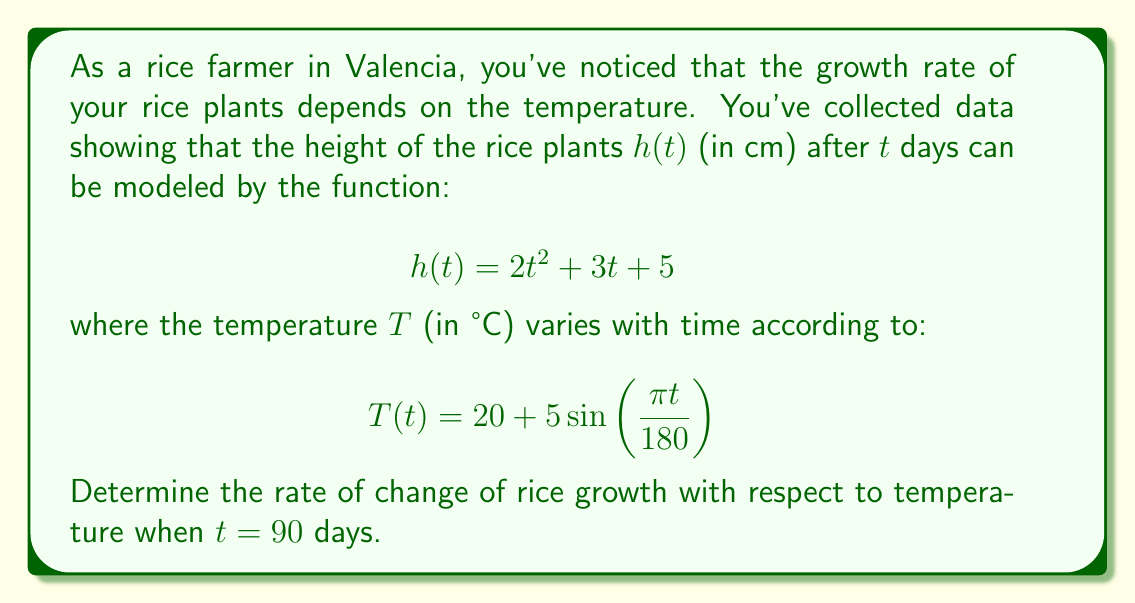Can you solve this math problem? To solve this problem, we need to use the chain rule from calculus. We want to find $\frac{dh}{dT}$ when $t = 90$.

Step 1: Find $\frac{dh}{dt}$
$$\frac{dh}{dt} = \frac{d}{dt}(2t^2 + 3t + 5) = 4t + 3$$

Step 2: Find $\frac{dT}{dt}$
$$\frac{dT}{dt} = \frac{d}{dt}(20 + 5\sin(\frac{\pi t}{180})) = 5 \cdot \frac{\pi}{180} \cos(\frac{\pi t}{180}) = \frac{\pi}{36} \cos(\frac{\pi t}{180})$$

Step 3: Use the chain rule
$$\frac{dh}{dT} = \frac{dh}{dt} \cdot \frac{dt}{dT} = \frac{dh}{dt} \cdot \frac{1}{\frac{dT}{dt}}$$

Step 4: Substitute $t = 90$ into the expressions for $\frac{dh}{dt}$ and $\frac{dT}{dt}$
$$\frac{dh}{dt}|_{t=90} = 4(90) + 3 = 363$$
$$\frac{dT}{dt}|_{t=90} = \frac{\pi}{36} \cos(\frac{\pi \cdot 90}{180}) = \frac{\pi}{36} \cos(\frac{\pi}{2}) = 0$$

Step 5: Calculate $\frac{dh}{dT}$ at $t = 90$
$$\frac{dh}{dT}|_{t=90} = \frac{363}{0}$$

This result is undefined, as we're dividing by zero. This means that at $t = 90$ days, the temperature is at its maximum or minimum point (in this case, maximum), and the rate of change of temperature with respect to time is momentarily zero.
Answer: The rate of change of rice growth with respect to temperature is undefined when $t = 90$ days, as $\frac{dT}{dt} = 0$ at this point. 